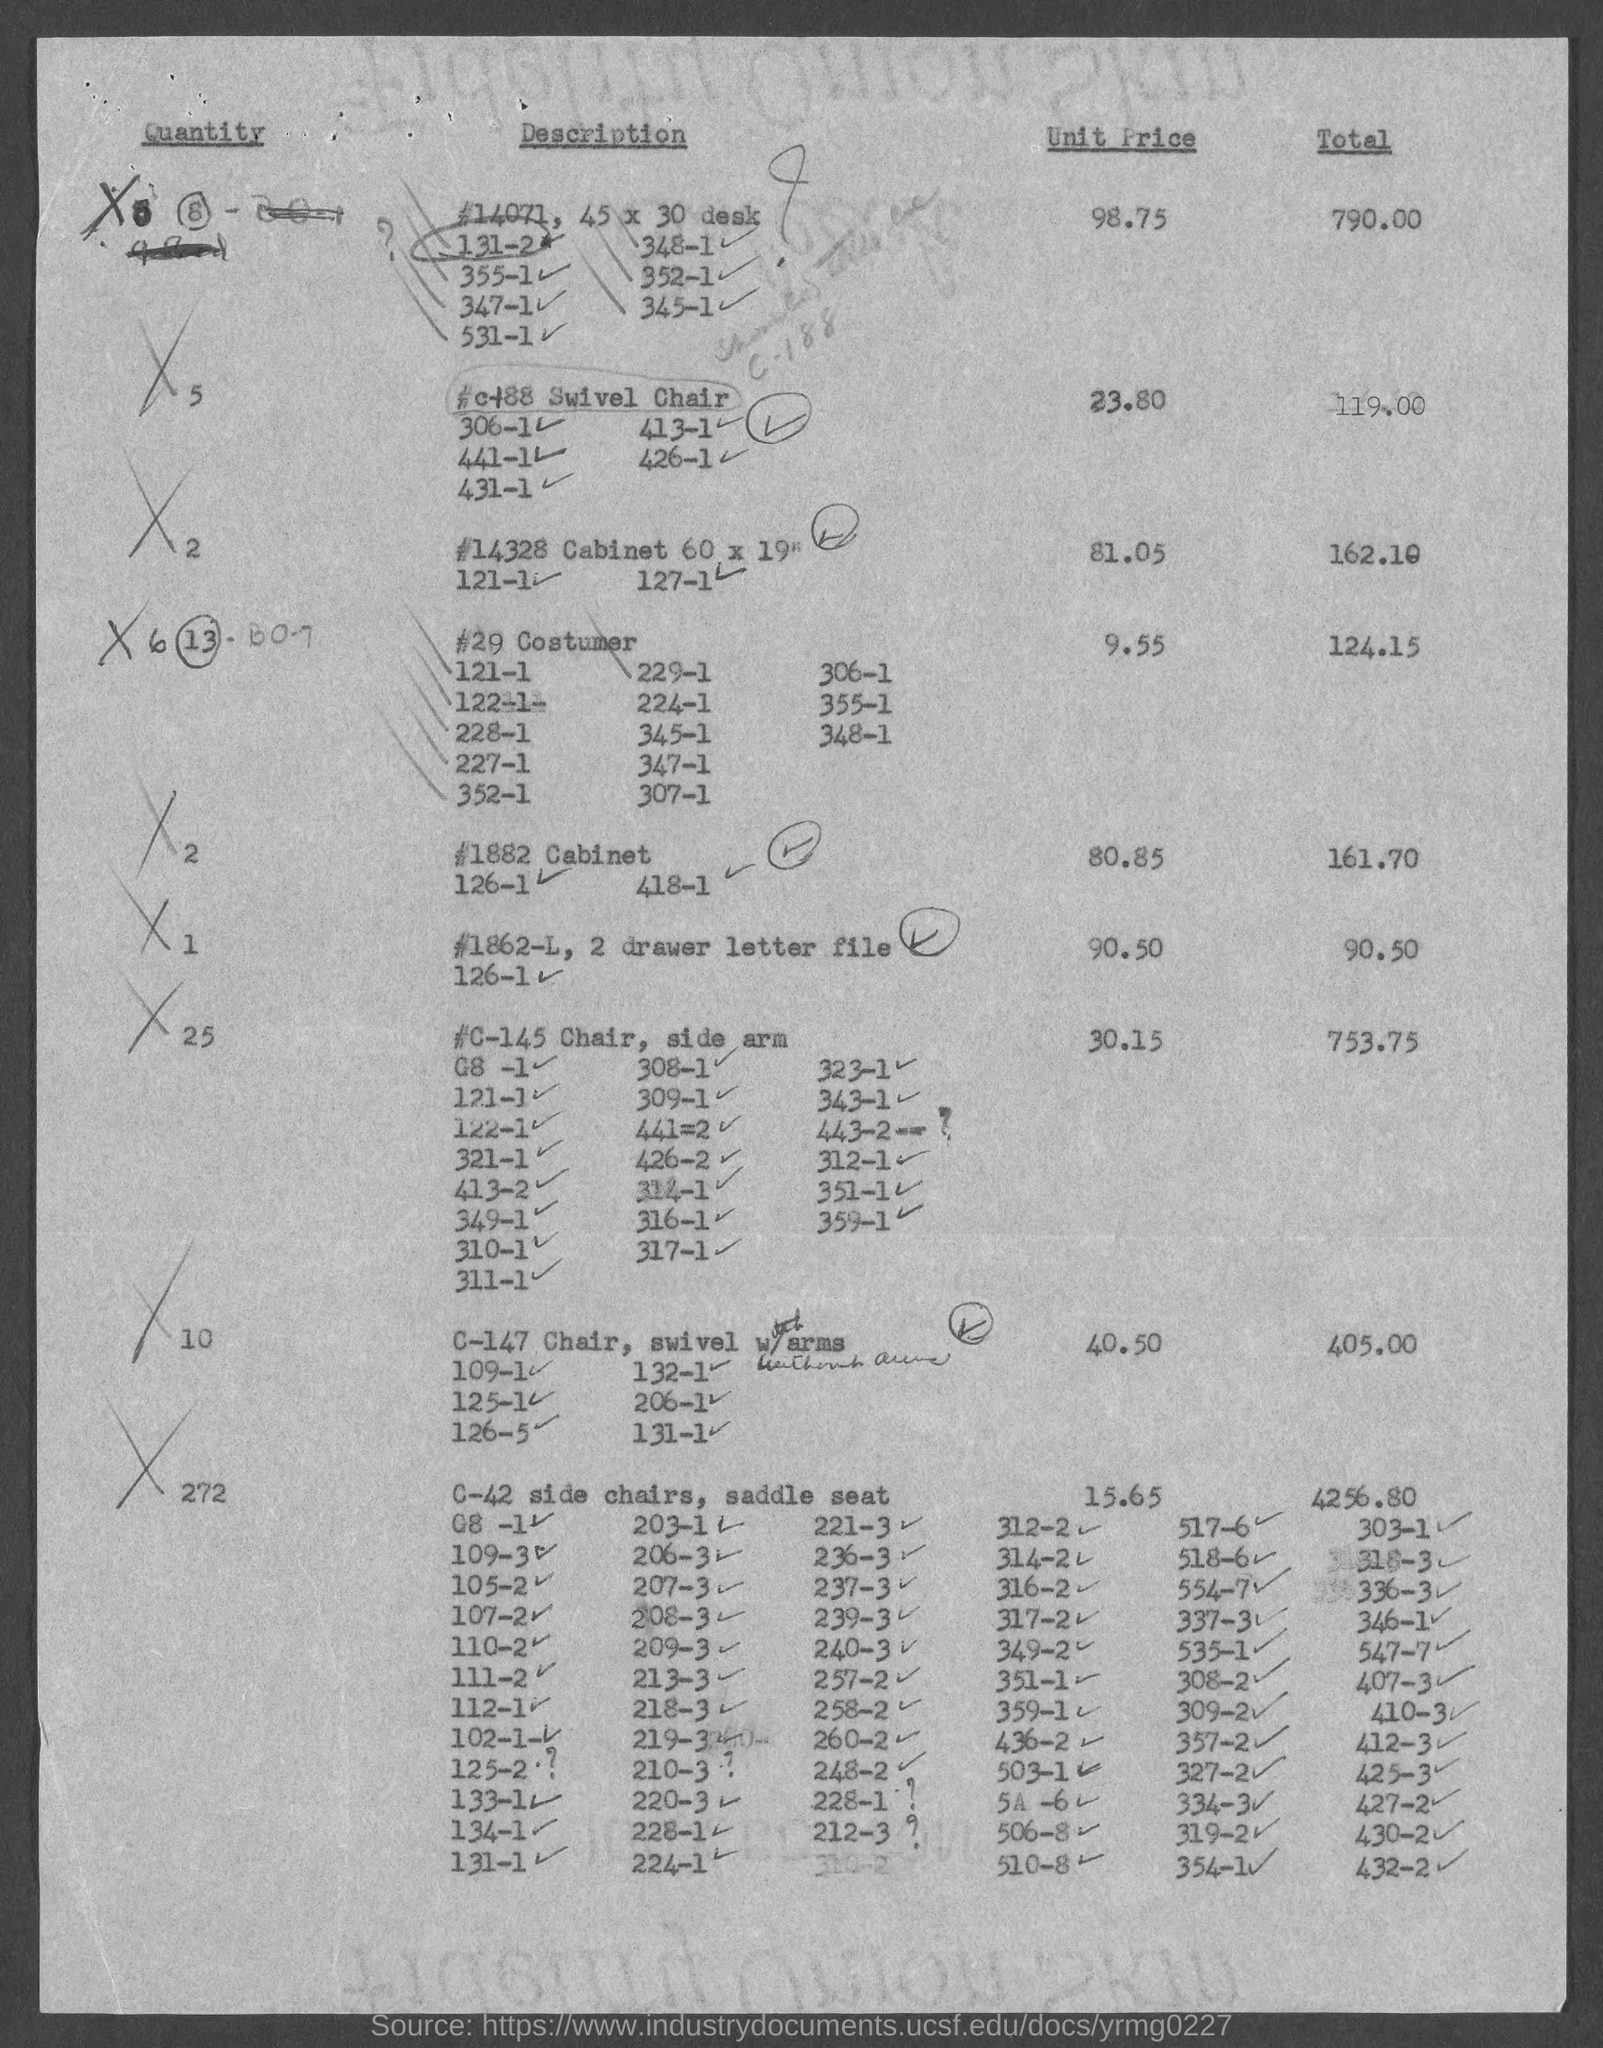What is the Unit Price for Quantity "1"?
Make the answer very short. 90.50. What is the Unit Price for Quantity "10"?
Make the answer very short. 40.50. What is the total value for quantity "25"?
Make the answer very short. 753.75. 